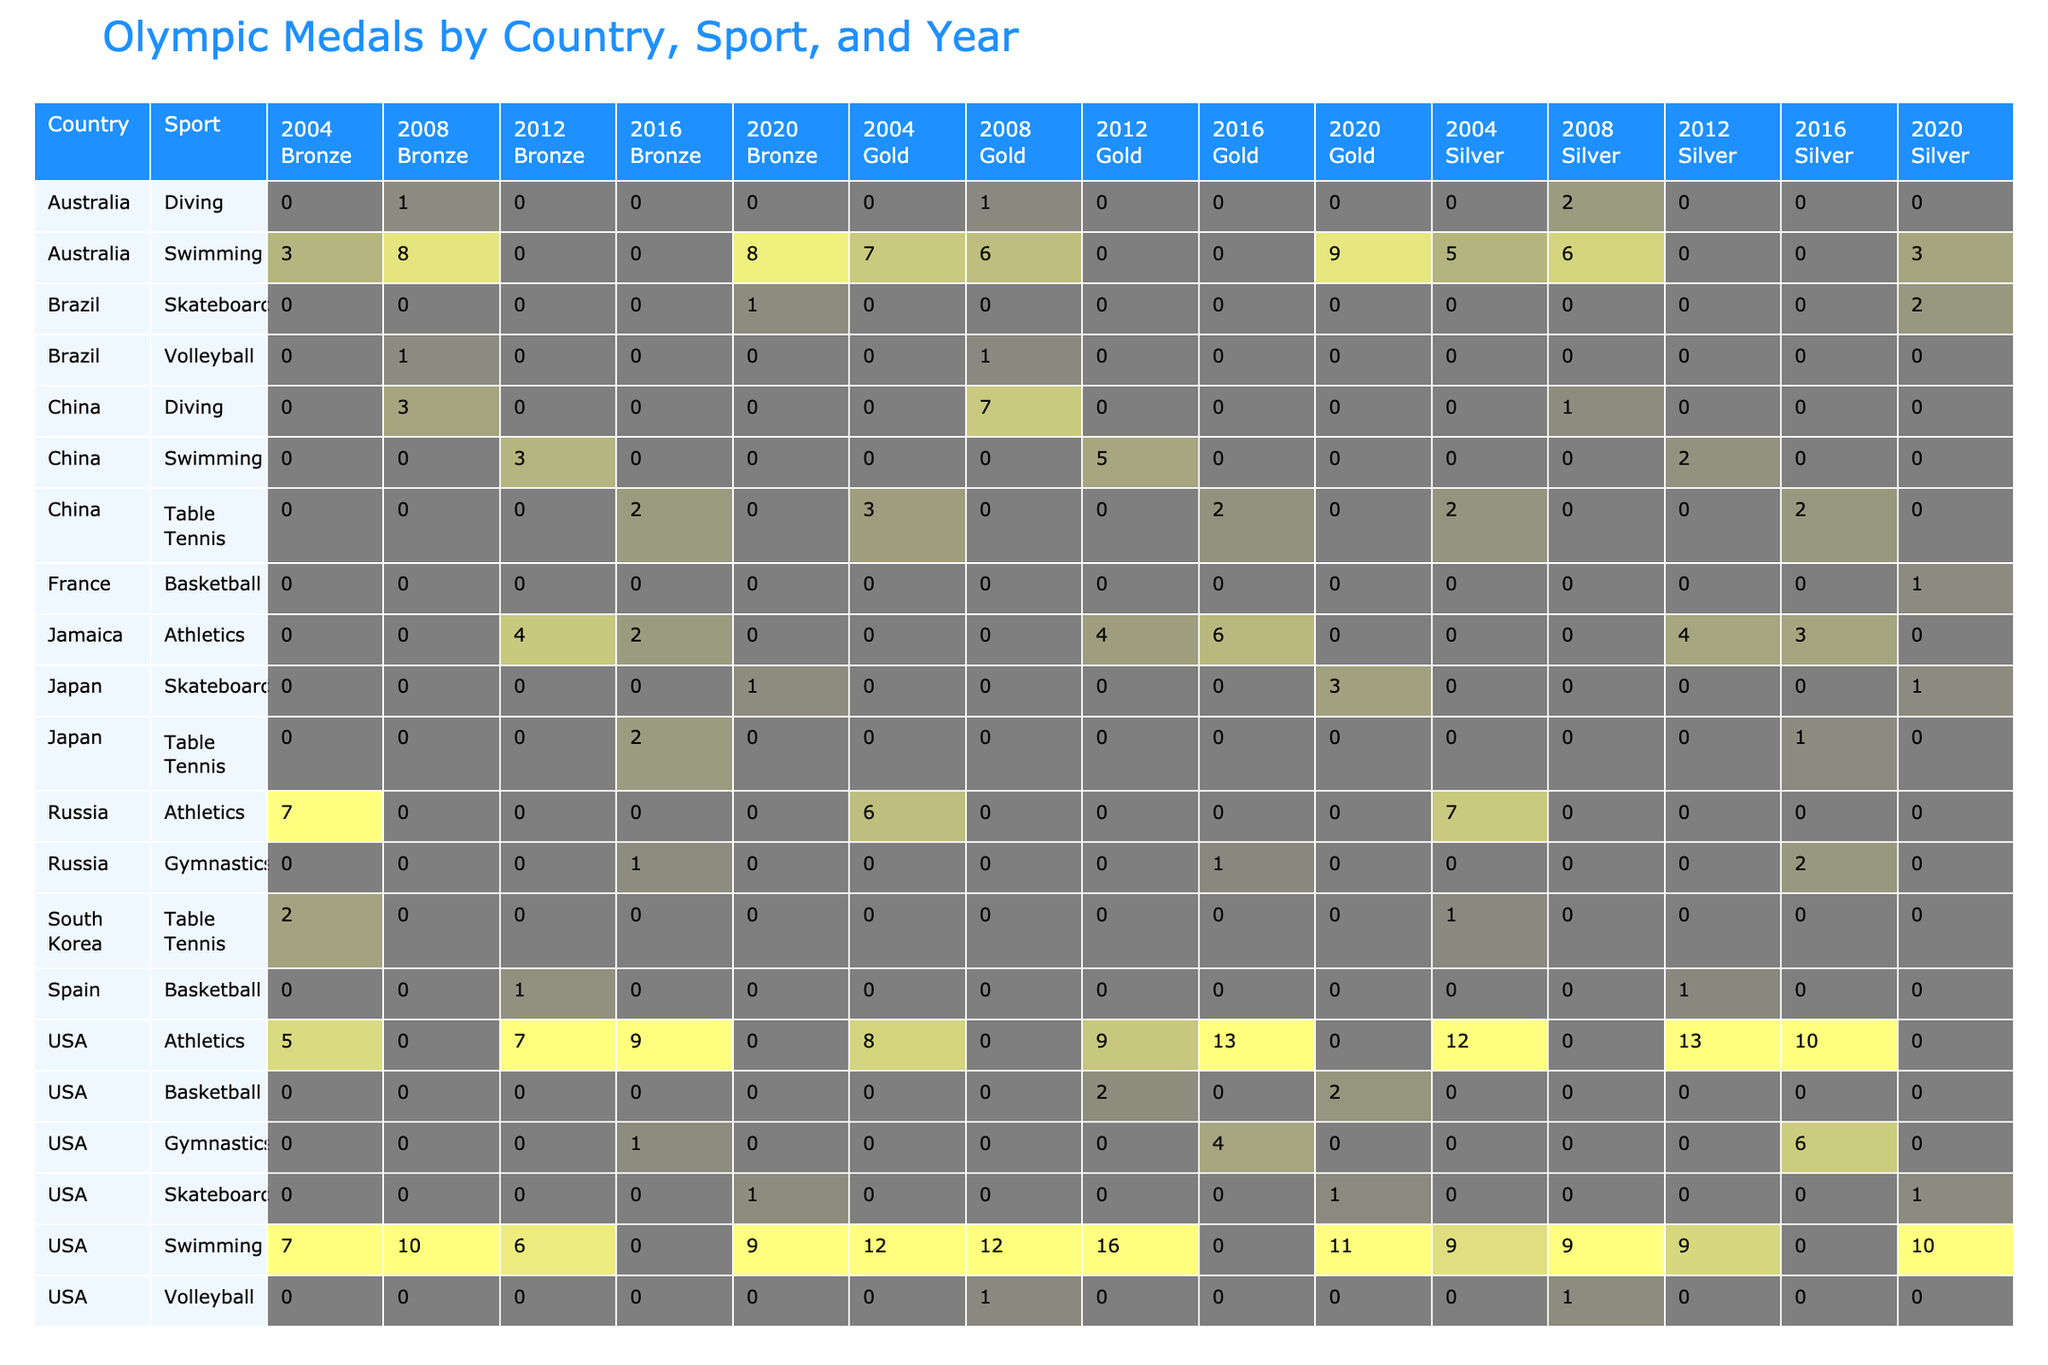What country won the most gold medals in skateboarding in 2020? Referring to the table, Japan has the highest number of gold medals in skateboarding for the year 2020, with a total of 3 gold medals.
Answer: Japan How many silver medals did the USA win in swimming over all the specified Olympic years? The total silver medals in swimming for the USA in the provided years (2004, 2008, 2012, and 2016) are 9 + 10 + 9 = 28.
Answer: 28 Did Brazil win any gold medals in skateboarding in 2020? Checking the skateboarding section for Brazil in 2020 shows that they won 0 gold medals.
Answer: No What is the total number of bronze medals won by Jamaica in athletics across the last 5 Olympics? Jamaica's bronze totals for athletics are 4 (2012) + 2 (2016) = 6. There are no bronze medals won by Jamaica in athletics during other Olympic years in the given data.
Answer: 6 Which country won more total medals in gymnastics: the USA or Russia in 2016? For the USA in gymnastics in 2016, the total is 4 gold + 6 silver + 1 bronze = 11 medals. For Russia, it is 1 gold + 2 silver + 1 bronze = 4 medals. Since 11 > 4, the USA won more medals in gymnastics in 2016.
Answer: USA What are the total gold medals won by the USA in swimming over the specified Olympic years? The gold medal counts for the USA in swimming are: 12 (2004) + 12 (2008) + 16 (2012) + 11 (2016) + 1 (2020) = 52 gold medals in total.
Answer: 52 Did any country win more than 2 gold medals in Table Tennis in 2016? A check on the table shows that only China won gold medals in Table Tennis, with 2 golds, hence no country won more than 2 golds in that sport in 2016.
Answer: No Which sport generated the most gold medals for the USA across all included Olympic years? The sports that contributed to gold medals for the USA are: Swimming (Total 52), Athletics (Total 30 across multiple years), and Gymnastics (4). Since Swimming produced the highest number of total golds at 52, it generated the most gold medals.
Answer: Swimming How many total medals (gold, silver, bronze) did Japan win in skateboarding in 2020? For Japan in skateboarding 2020, the total is 3 gold + 1 silver + 1 bronze = 5 medals in total.
Answer: 5 